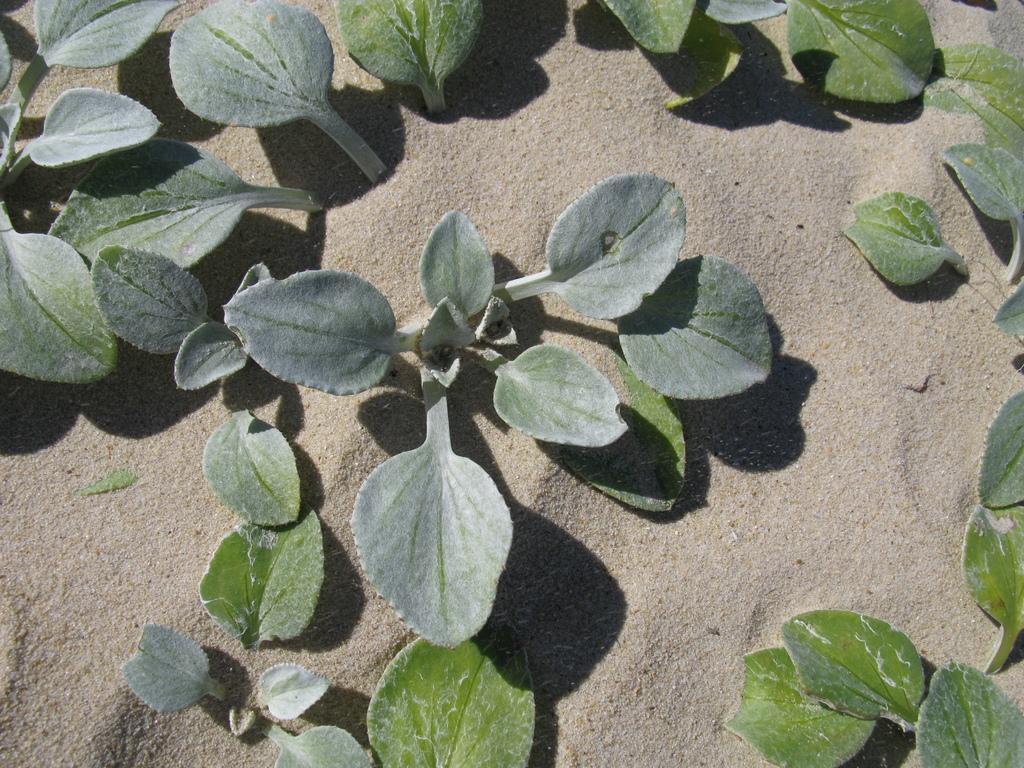How would you summarize this image in a sentence or two? In this image we can see plants in the sand. 